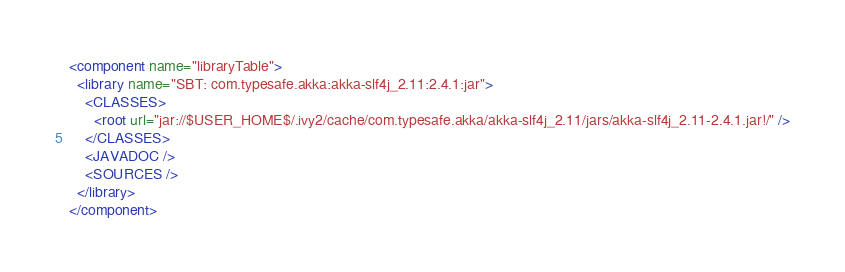<code> <loc_0><loc_0><loc_500><loc_500><_XML_><component name="libraryTable">
  <library name="SBT: com.typesafe.akka:akka-slf4j_2.11:2.4.1:jar">
    <CLASSES>
      <root url="jar://$USER_HOME$/.ivy2/cache/com.typesafe.akka/akka-slf4j_2.11/jars/akka-slf4j_2.11-2.4.1.jar!/" />
    </CLASSES>
    <JAVADOC />
    <SOURCES />
  </library>
</component></code> 